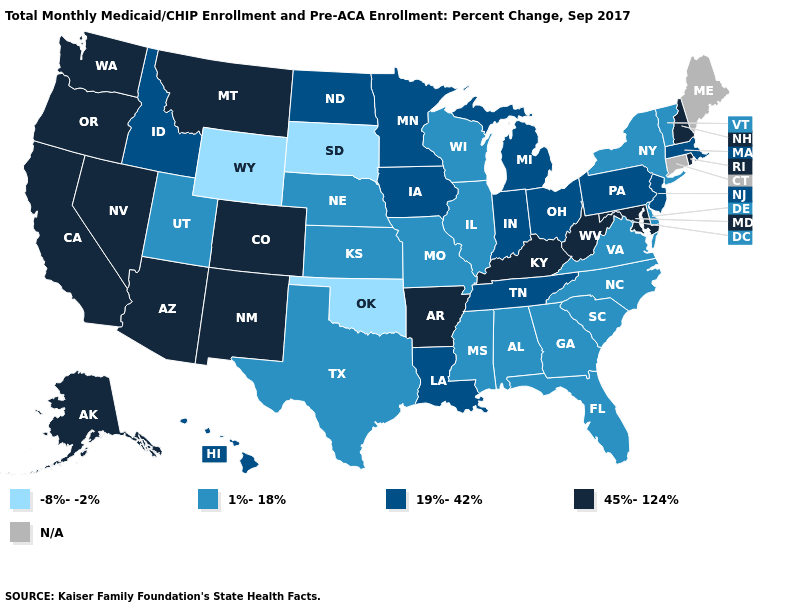Does the first symbol in the legend represent the smallest category?
Short answer required. Yes. Among the states that border South Dakota , which have the lowest value?
Short answer required. Wyoming. What is the highest value in the South ?
Concise answer only. 45%-124%. What is the highest value in the USA?
Concise answer only. 45%-124%. What is the highest value in states that border Vermont?
Be succinct. 45%-124%. What is the lowest value in the West?
Give a very brief answer. -8%--2%. Does Vermont have the lowest value in the Northeast?
Short answer required. Yes. What is the value of Virginia?
Be succinct. 1%-18%. Name the states that have a value in the range N/A?
Be succinct. Connecticut, Maine. Does the map have missing data?
Be succinct. Yes. Which states hav the highest value in the Northeast?
Keep it brief. New Hampshire, Rhode Island. Does Wisconsin have the lowest value in the MidWest?
Give a very brief answer. No. What is the value of Massachusetts?
Be succinct. 19%-42%. Among the states that border Oregon , does California have the highest value?
Keep it brief. Yes. 